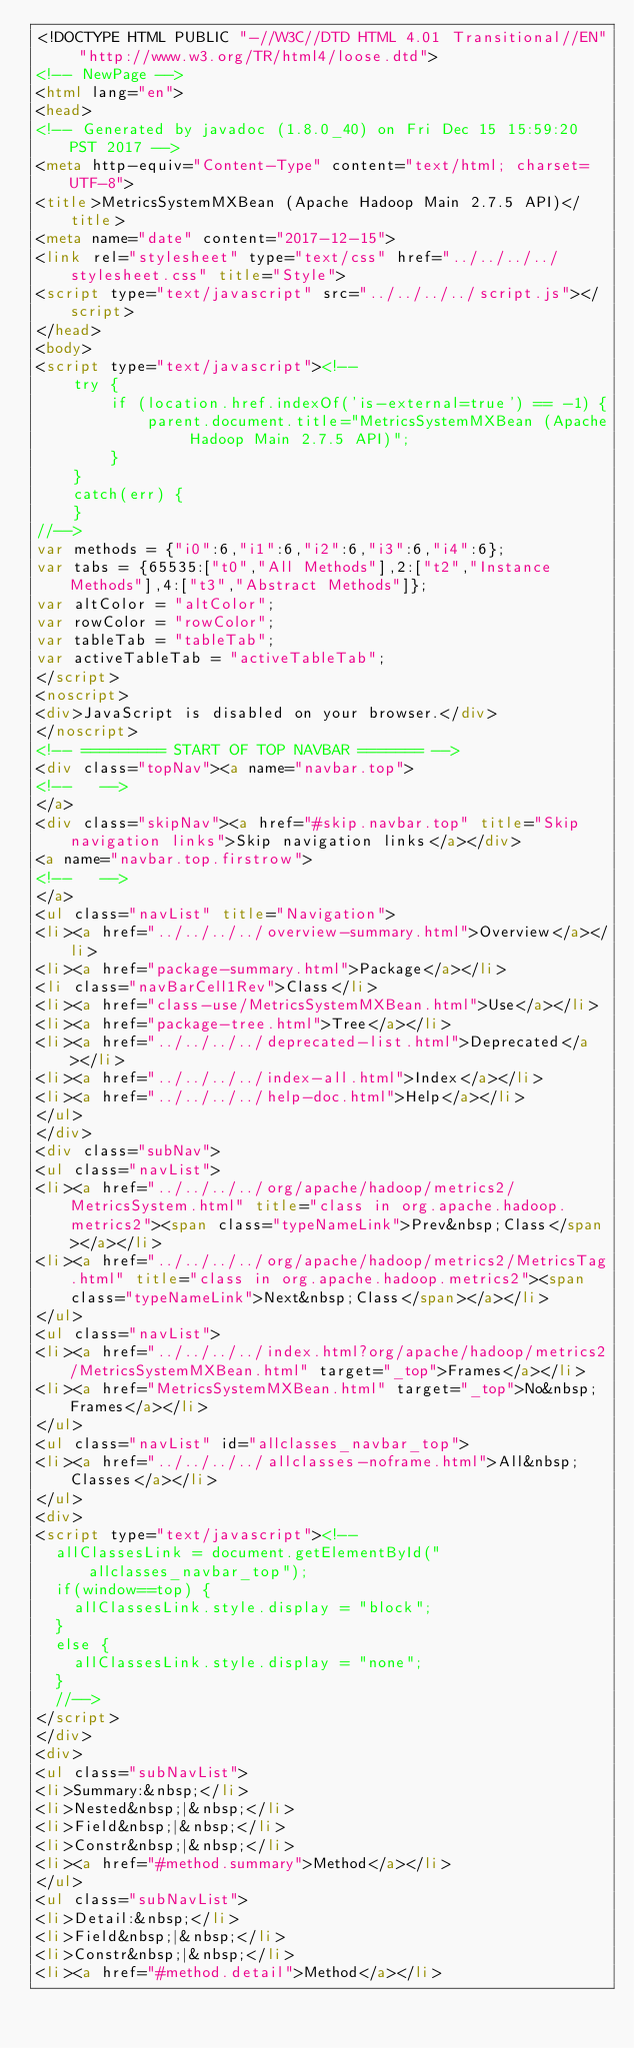Convert code to text. <code><loc_0><loc_0><loc_500><loc_500><_HTML_><!DOCTYPE HTML PUBLIC "-//W3C//DTD HTML 4.01 Transitional//EN" "http://www.w3.org/TR/html4/loose.dtd">
<!-- NewPage -->
<html lang="en">
<head>
<!-- Generated by javadoc (1.8.0_40) on Fri Dec 15 15:59:20 PST 2017 -->
<meta http-equiv="Content-Type" content="text/html; charset=UTF-8">
<title>MetricsSystemMXBean (Apache Hadoop Main 2.7.5 API)</title>
<meta name="date" content="2017-12-15">
<link rel="stylesheet" type="text/css" href="../../../../stylesheet.css" title="Style">
<script type="text/javascript" src="../../../../script.js"></script>
</head>
<body>
<script type="text/javascript"><!--
    try {
        if (location.href.indexOf('is-external=true') == -1) {
            parent.document.title="MetricsSystemMXBean (Apache Hadoop Main 2.7.5 API)";
        }
    }
    catch(err) {
    }
//-->
var methods = {"i0":6,"i1":6,"i2":6,"i3":6,"i4":6};
var tabs = {65535:["t0","All Methods"],2:["t2","Instance Methods"],4:["t3","Abstract Methods"]};
var altColor = "altColor";
var rowColor = "rowColor";
var tableTab = "tableTab";
var activeTableTab = "activeTableTab";
</script>
<noscript>
<div>JavaScript is disabled on your browser.</div>
</noscript>
<!-- ========= START OF TOP NAVBAR ======= -->
<div class="topNav"><a name="navbar.top">
<!--   -->
</a>
<div class="skipNav"><a href="#skip.navbar.top" title="Skip navigation links">Skip navigation links</a></div>
<a name="navbar.top.firstrow">
<!--   -->
</a>
<ul class="navList" title="Navigation">
<li><a href="../../../../overview-summary.html">Overview</a></li>
<li><a href="package-summary.html">Package</a></li>
<li class="navBarCell1Rev">Class</li>
<li><a href="class-use/MetricsSystemMXBean.html">Use</a></li>
<li><a href="package-tree.html">Tree</a></li>
<li><a href="../../../../deprecated-list.html">Deprecated</a></li>
<li><a href="../../../../index-all.html">Index</a></li>
<li><a href="../../../../help-doc.html">Help</a></li>
</ul>
</div>
<div class="subNav">
<ul class="navList">
<li><a href="../../../../org/apache/hadoop/metrics2/MetricsSystem.html" title="class in org.apache.hadoop.metrics2"><span class="typeNameLink">Prev&nbsp;Class</span></a></li>
<li><a href="../../../../org/apache/hadoop/metrics2/MetricsTag.html" title="class in org.apache.hadoop.metrics2"><span class="typeNameLink">Next&nbsp;Class</span></a></li>
</ul>
<ul class="navList">
<li><a href="../../../../index.html?org/apache/hadoop/metrics2/MetricsSystemMXBean.html" target="_top">Frames</a></li>
<li><a href="MetricsSystemMXBean.html" target="_top">No&nbsp;Frames</a></li>
</ul>
<ul class="navList" id="allclasses_navbar_top">
<li><a href="../../../../allclasses-noframe.html">All&nbsp;Classes</a></li>
</ul>
<div>
<script type="text/javascript"><!--
  allClassesLink = document.getElementById("allclasses_navbar_top");
  if(window==top) {
    allClassesLink.style.display = "block";
  }
  else {
    allClassesLink.style.display = "none";
  }
  //-->
</script>
</div>
<div>
<ul class="subNavList">
<li>Summary:&nbsp;</li>
<li>Nested&nbsp;|&nbsp;</li>
<li>Field&nbsp;|&nbsp;</li>
<li>Constr&nbsp;|&nbsp;</li>
<li><a href="#method.summary">Method</a></li>
</ul>
<ul class="subNavList">
<li>Detail:&nbsp;</li>
<li>Field&nbsp;|&nbsp;</li>
<li>Constr&nbsp;|&nbsp;</li>
<li><a href="#method.detail">Method</a></li></code> 